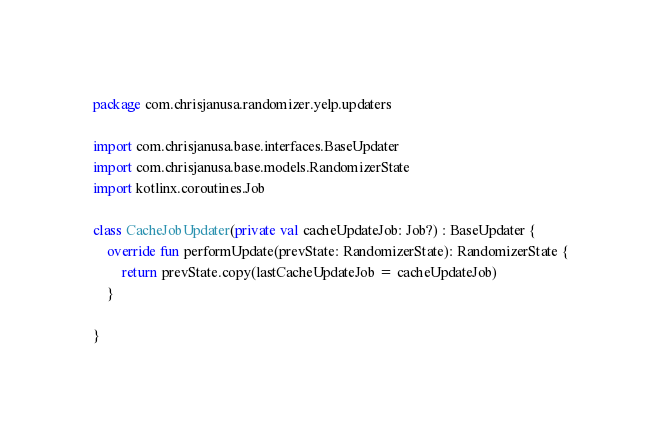Convert code to text. <code><loc_0><loc_0><loc_500><loc_500><_Kotlin_>package com.chrisjanusa.randomizer.yelp.updaters

import com.chrisjanusa.base.interfaces.BaseUpdater
import com.chrisjanusa.base.models.RandomizerState
import kotlinx.coroutines.Job

class CacheJobUpdater(private val cacheUpdateJob: Job?) : BaseUpdater {
    override fun performUpdate(prevState: RandomizerState): RandomizerState {
        return prevState.copy(lastCacheUpdateJob = cacheUpdateJob)
    }

}</code> 